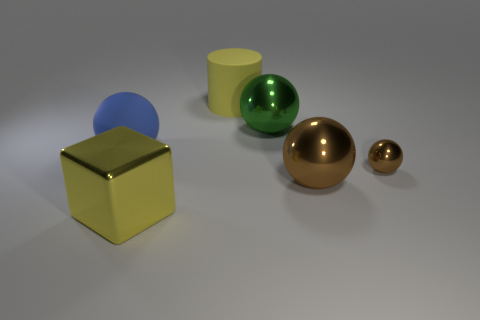Are there any blue objects to the right of the green sphere?
Give a very brief answer. No. There is a large rubber sphere; is it the same color as the big metal object left of the big cylinder?
Ensure brevity in your answer.  No. What color is the big ball that is to the left of the yellow object in front of the rubber thing to the left of the yellow cylinder?
Offer a very short reply. Blue. Are there any other large metallic objects that have the same shape as the blue thing?
Keep it short and to the point. Yes. There is a rubber cylinder that is the same size as the blue thing; what color is it?
Make the answer very short. Yellow. There is a yellow object behind the yellow block; what is it made of?
Offer a very short reply. Rubber. Is the shape of the yellow object that is on the left side of the yellow matte cylinder the same as the rubber thing that is behind the blue thing?
Provide a short and direct response. No. Are there the same number of yellow shiny objects that are behind the blue object and small brown metal balls?
Keep it short and to the point. No. How many brown things have the same material as the green thing?
Give a very brief answer. 2. What is the color of the cube that is the same material as the small thing?
Your answer should be very brief. Yellow. 